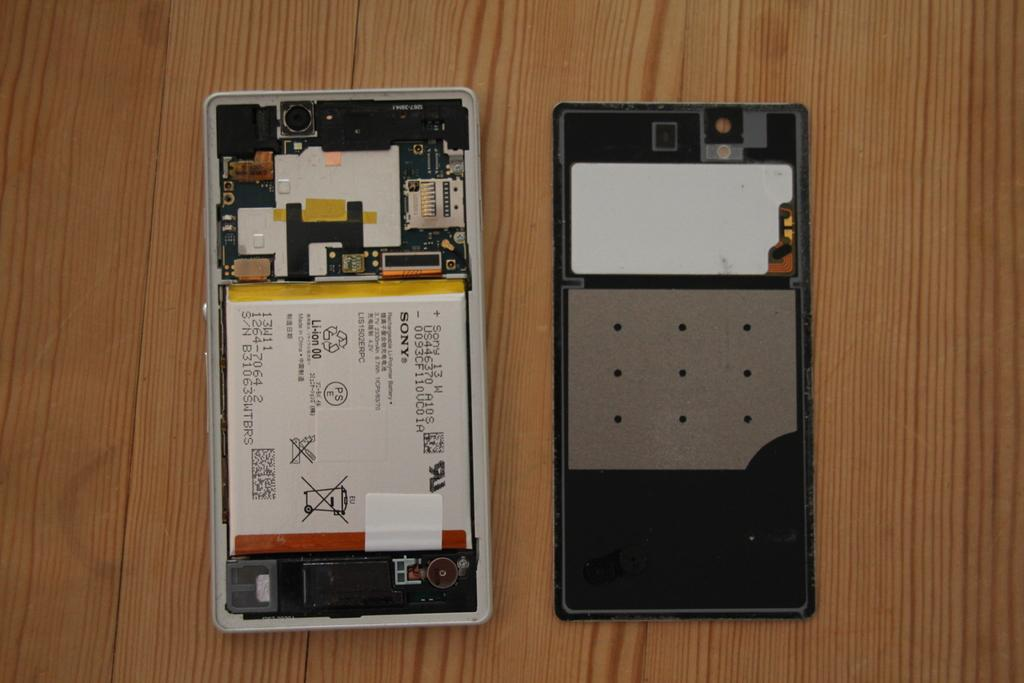<image>
Present a compact description of the photo's key features. A phone opened to show its insides with the letters PSE in a circle visible 